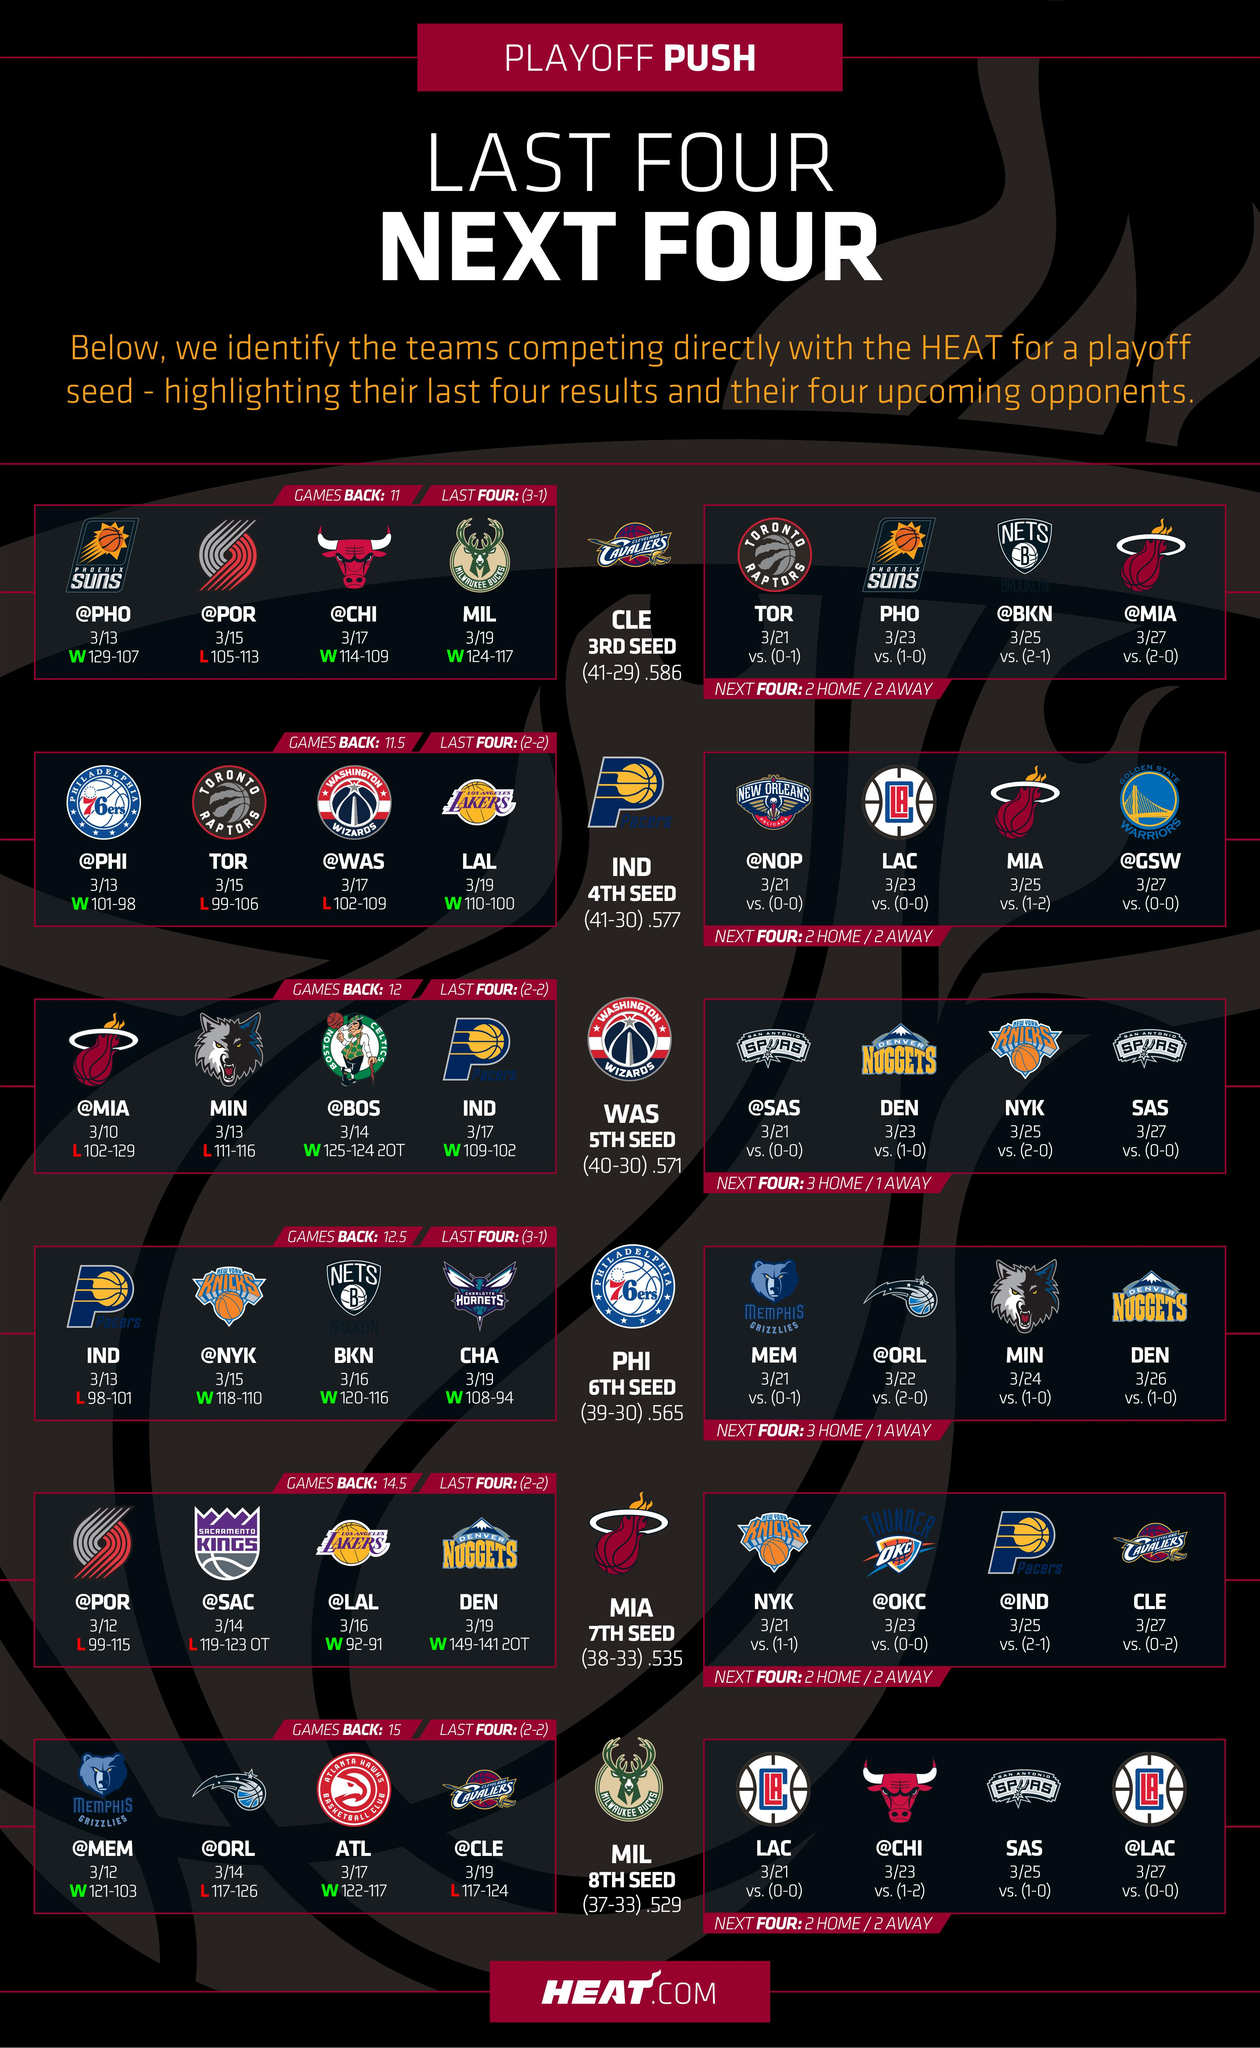Point out several critical features in this image. Six rows can be found in this infographic. 